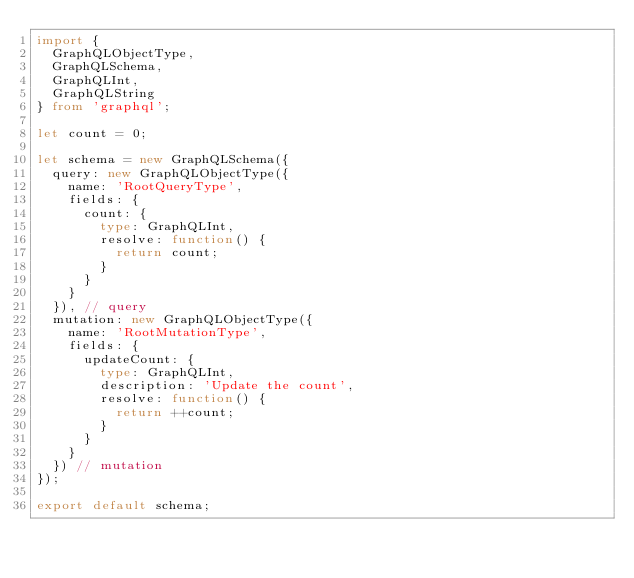<code> <loc_0><loc_0><loc_500><loc_500><_TypeScript_>import {
  GraphQLObjectType,
  GraphQLSchema,
  GraphQLInt,
  GraphQLString
} from 'graphql';

let count = 0;

let schema = new GraphQLSchema({
  query: new GraphQLObjectType({
    name: 'RootQueryType',
    fields: {
      count: {
        type: GraphQLInt,
        resolve: function() {
          return count;
        }
      }
    }
  }), // query
  mutation: new GraphQLObjectType({
    name: 'RootMutationType',
    fields: {
      updateCount: {
        type: GraphQLInt,
        description: 'Update the count',
        resolve: function() {
          return ++count;
        }
      }
    }
  }) // mutation
});

export default schema;
</code> 